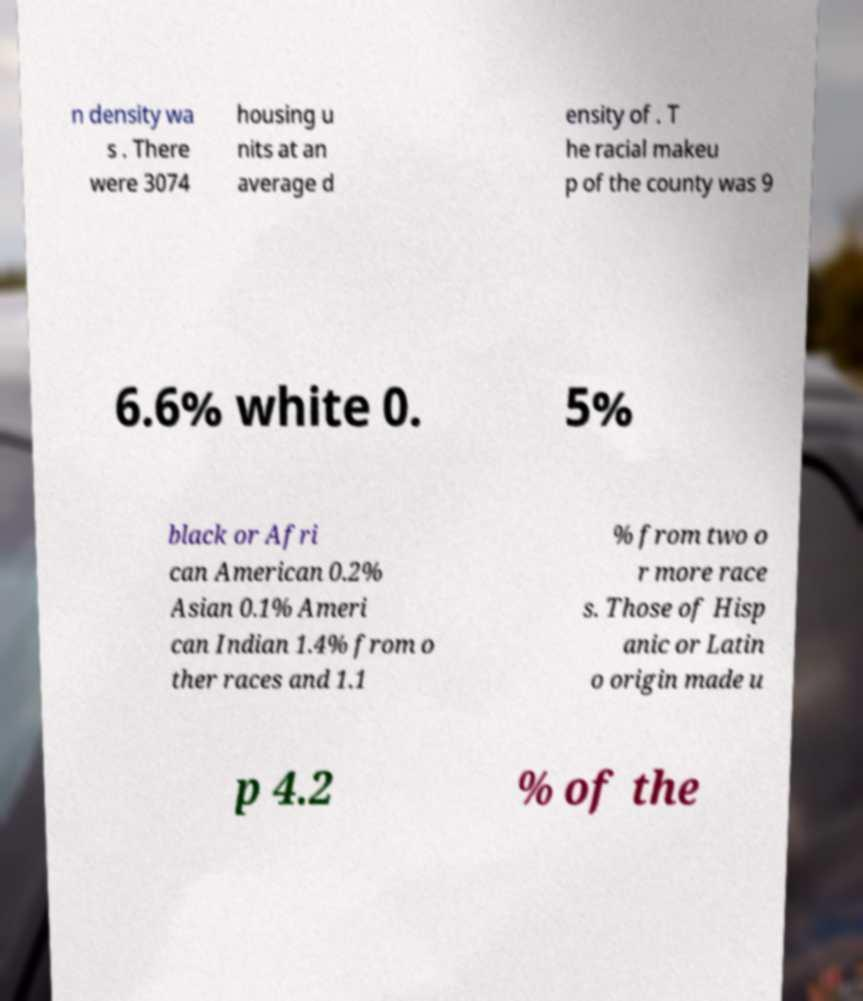I need the written content from this picture converted into text. Can you do that? n density wa s . There were 3074 housing u nits at an average d ensity of . T he racial makeu p of the county was 9 6.6% white 0. 5% black or Afri can American 0.2% Asian 0.1% Ameri can Indian 1.4% from o ther races and 1.1 % from two o r more race s. Those of Hisp anic or Latin o origin made u p 4.2 % of the 